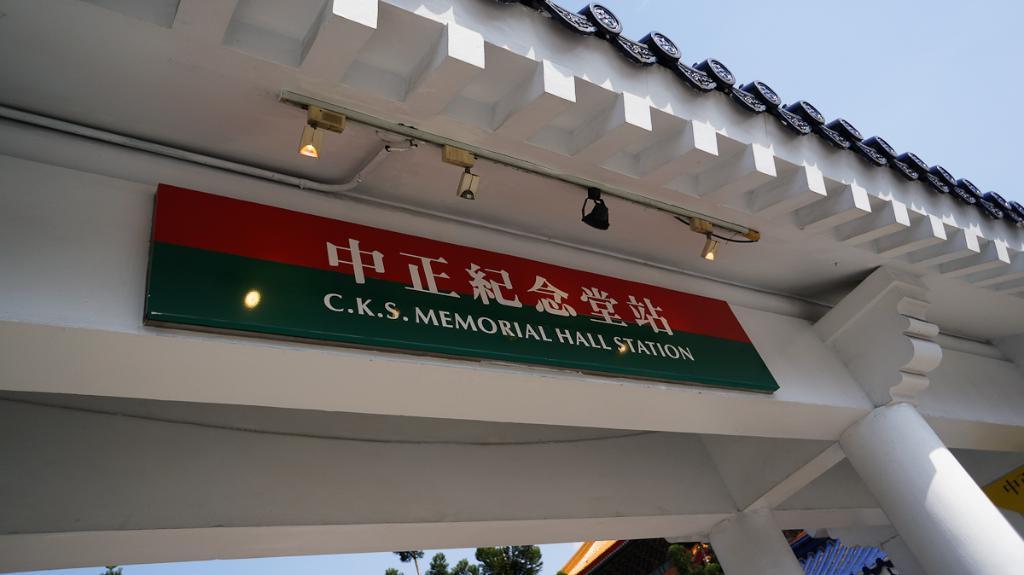Can you describe this image briefly? In this image I can see white colour arch in the front and on it I can see a board and few lights. I can also see something is written on the board. On the bottom side of this image I can see few trees, a building and the sky. On the right side of this image I can see a yellow colour thing. 